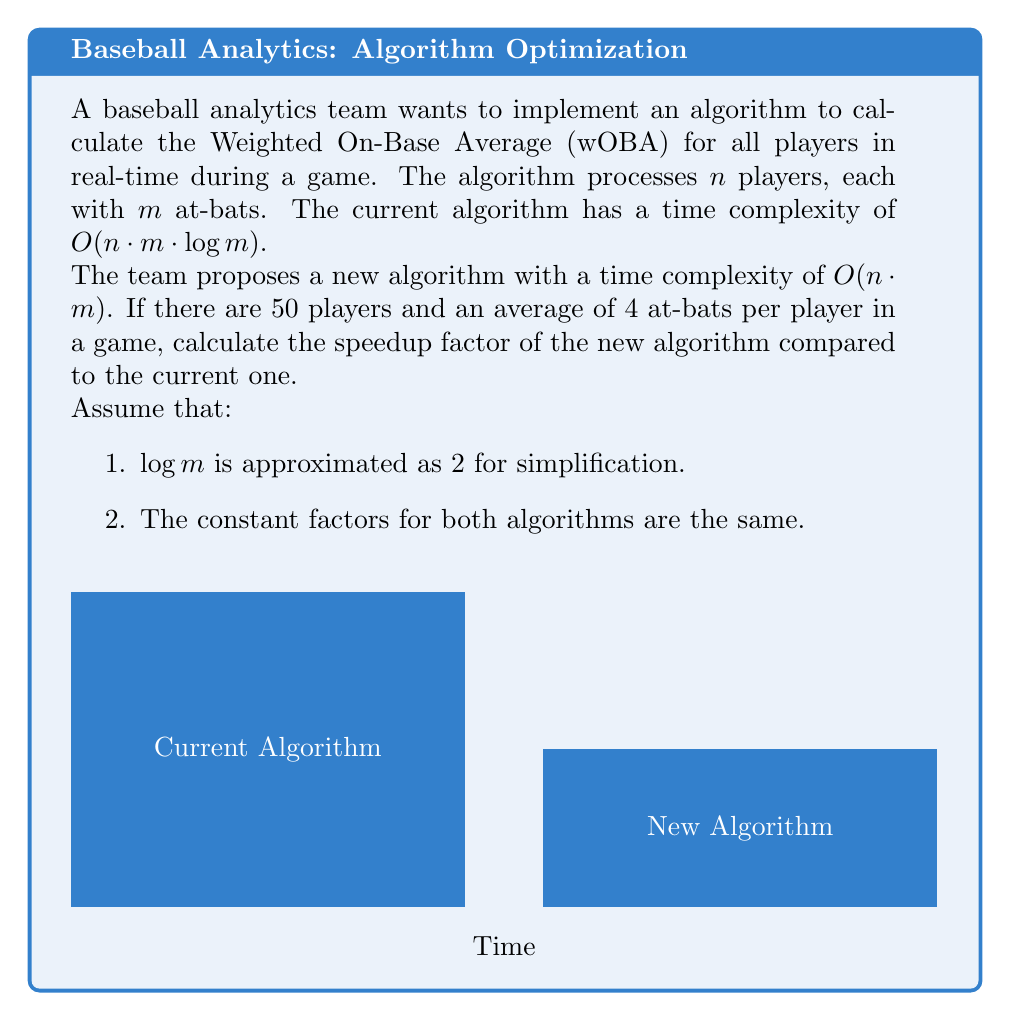What is the answer to this math problem? Let's approach this step-by-step:

1) First, let's define our variables:
   $n = 50$ (number of players)
   $m = 4$ (average number of at-bats per player)
   $\log m \approx 2$ (given approximation)

2) Current algorithm time complexity: $O(n \cdot m \cdot \log m)$
   New algorithm time complexity: $O(n \cdot m)$

3) Let's calculate the relative time for each algorithm:
   Current: $T_1 = n \cdot m \cdot \log m = 50 \cdot 4 \cdot 2 = 400$
   New: $T_2 = n \cdot m = 50 \cdot 4 = 200$

4) The speedup factor is calculated by dividing the time of the current algorithm by the time of the new algorithm:

   Speedup = $\frac{T_1}{T_2} = \frac{400}{200} = 2$

Therefore, the new algorithm is 2 times faster than the current algorithm for the given conditions.

This speedup is significant in real-time analytics, allowing for quicker decision-making during the game.
Answer: 2 